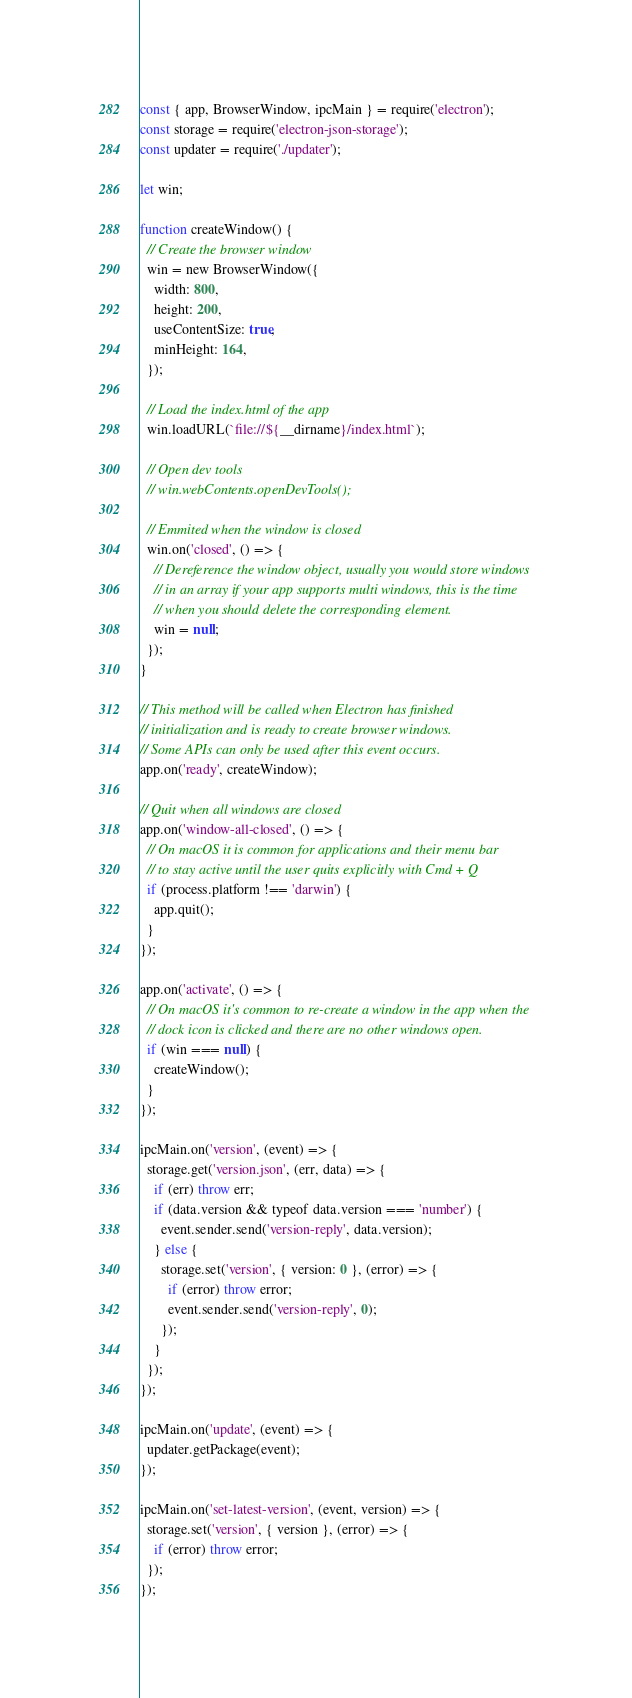<code> <loc_0><loc_0><loc_500><loc_500><_JavaScript_>const { app, BrowserWindow, ipcMain } = require('electron');
const storage = require('electron-json-storage');
const updater = require('./updater');

let win;

function createWindow() {
  // Create the browser window
  win = new BrowserWindow({
    width: 800,
    height: 200,
    useContentSize: true,
    minHeight: 164,
  });

  // Load the index.html of the app
  win.loadURL(`file://${__dirname}/index.html`);

  // Open dev tools
  // win.webContents.openDevTools();

  // Emmited when the window is closed
  win.on('closed', () => {
    // Dereference the window object, usually you would store windows
    // in an array if your app supports multi windows, this is the time
    // when you should delete the corresponding element.
    win = null;
  });
}

// This method will be called when Electron has finished
// initialization and is ready to create browser windows.
// Some APIs can only be used after this event occurs.
app.on('ready', createWindow);

// Quit when all windows are closed
app.on('window-all-closed', () => {
  // On macOS it is common for applications and their menu bar
  // to stay active until the user quits explicitly with Cmd + Q
  if (process.platform !== 'darwin') {
    app.quit();
  }
});

app.on('activate', () => {
  // On macOS it's common to re-create a window in the app when the
  // dock icon is clicked and there are no other windows open.
  if (win === null) {
    createWindow();
  }
});

ipcMain.on('version', (event) => {
  storage.get('version.json', (err, data) => {
    if (err) throw err;
    if (data.version && typeof data.version === 'number') {
      event.sender.send('version-reply', data.version);
    } else {
      storage.set('version', { version: 0 }, (error) => {
        if (error) throw error;
        event.sender.send('version-reply', 0);
      });
    }
  });
});

ipcMain.on('update', (event) => {
  updater.getPackage(event);
});

ipcMain.on('set-latest-version', (event, version) => {
  storage.set('version', { version }, (error) => {
    if (error) throw error;
  });
});
</code> 